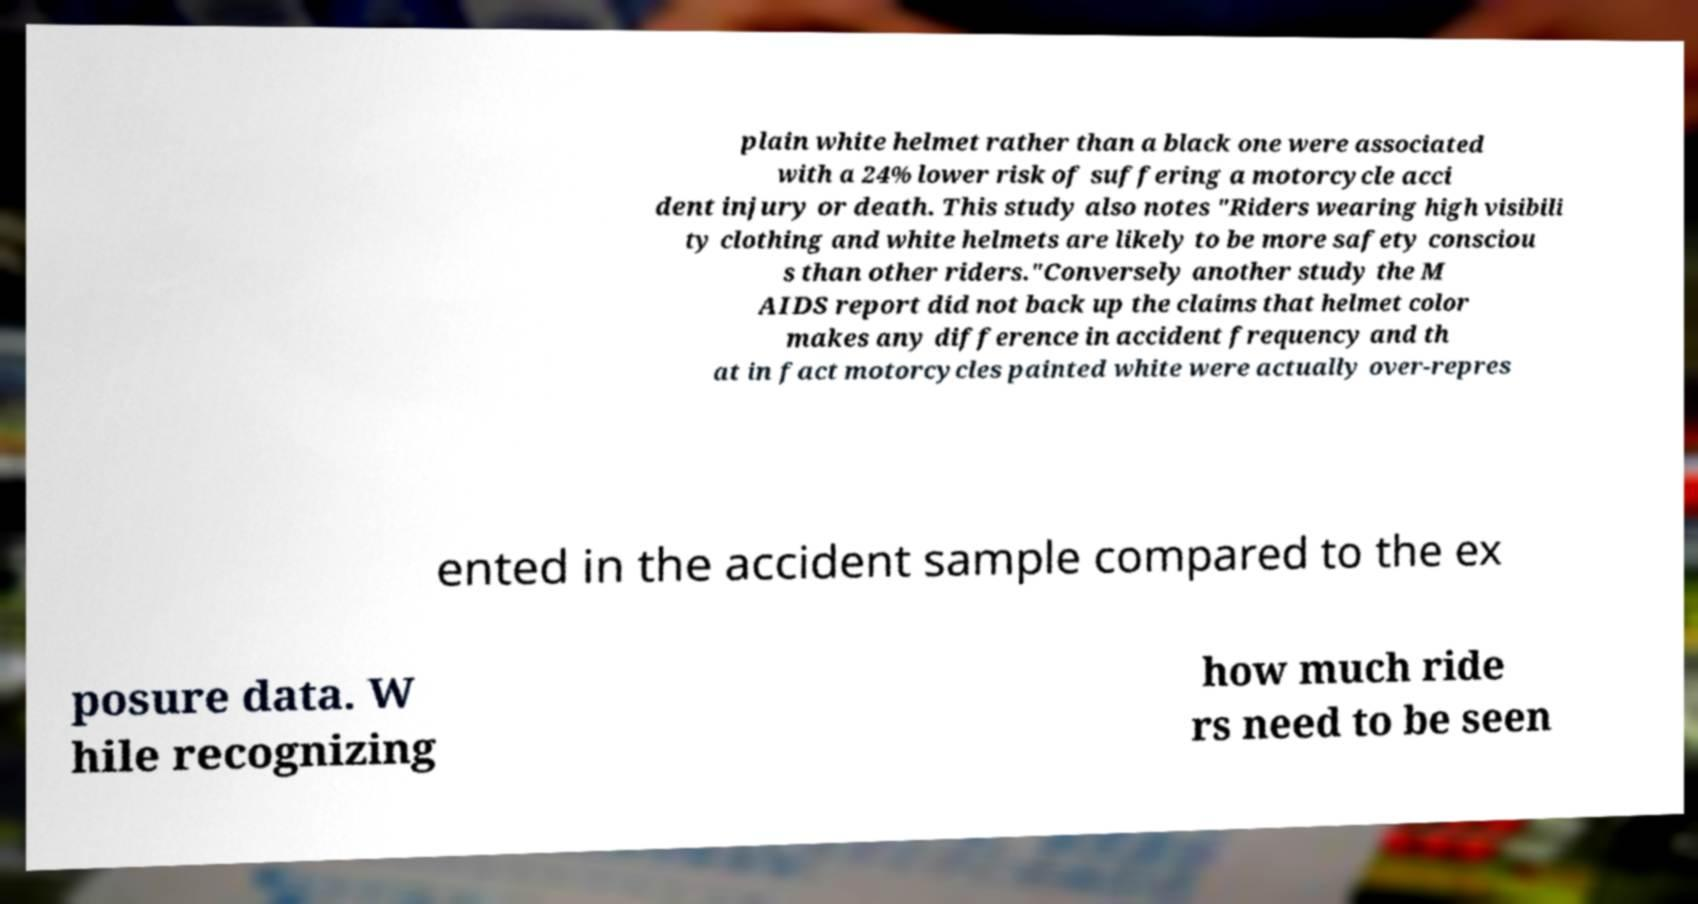Can you read and provide the text displayed in the image?This photo seems to have some interesting text. Can you extract and type it out for me? plain white helmet rather than a black one were associated with a 24% lower risk of suffering a motorcycle acci dent injury or death. This study also notes "Riders wearing high visibili ty clothing and white helmets are likely to be more safety consciou s than other riders."Conversely another study the M AIDS report did not back up the claims that helmet color makes any difference in accident frequency and th at in fact motorcycles painted white were actually over-repres ented in the accident sample compared to the ex posure data. W hile recognizing how much ride rs need to be seen 